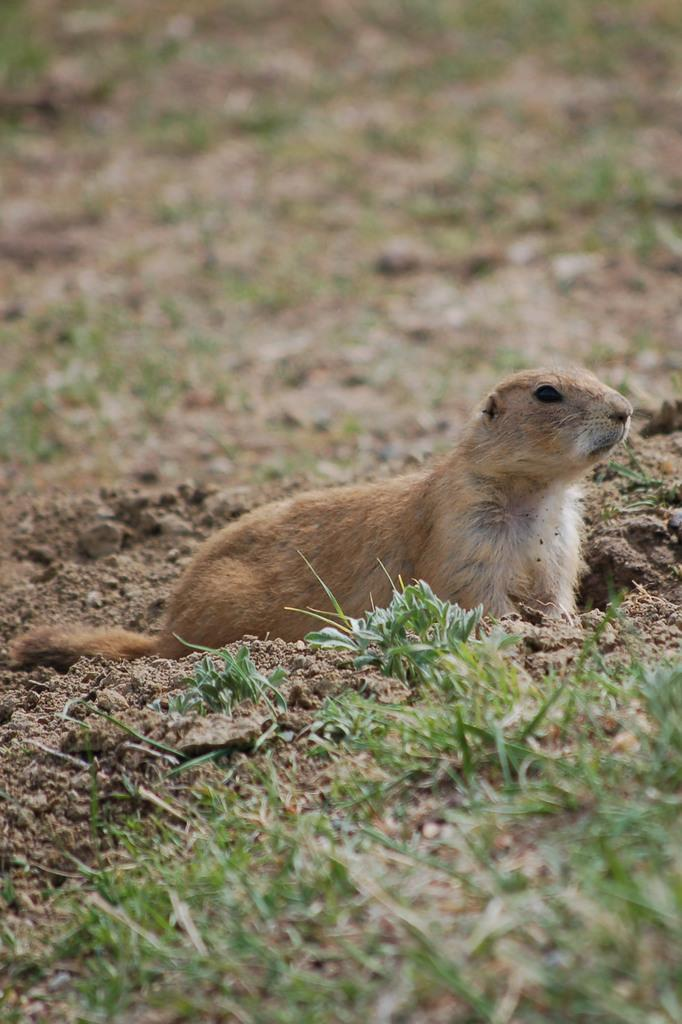What is the main subject in the center of the image? There is an animal in the center of the image. What type of vegetation can be seen at the bottom of the image? There is grass at the bottom of the image. What type of sound does the animal make in the image? The image does not provide any information about the sound the animal makes. 